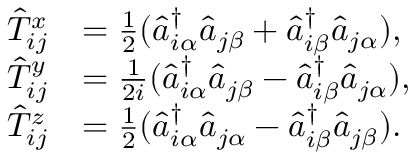Convert formula to latex. <formula><loc_0><loc_0><loc_500><loc_500>\begin{array} { r l } { \hat { T } _ { i j } ^ { x } } & { = \frac { 1 } { 2 } ( \hat { a } _ { i \alpha } ^ { \dagger } \hat { a } _ { j \beta } + \hat { a } _ { i \beta } ^ { \dagger } \hat { a } _ { j \alpha } ) , } \\ { \hat { T } _ { i j } ^ { y } } & { = \frac { 1 } { 2 i } ( \hat { a } _ { i \alpha } ^ { \dagger } \hat { a } _ { j \beta } - \hat { a } _ { i \beta } ^ { \dagger } \hat { a } _ { j \alpha } ) , } \\ { \hat { T } _ { i j } ^ { z } } & { = \frac { 1 } { 2 } ( \hat { a } _ { i \alpha } ^ { \dagger } \hat { a } _ { j \alpha } - \hat { a } _ { i \beta } ^ { \dagger } \hat { a } _ { j \beta } ) . } \end{array}</formula> 